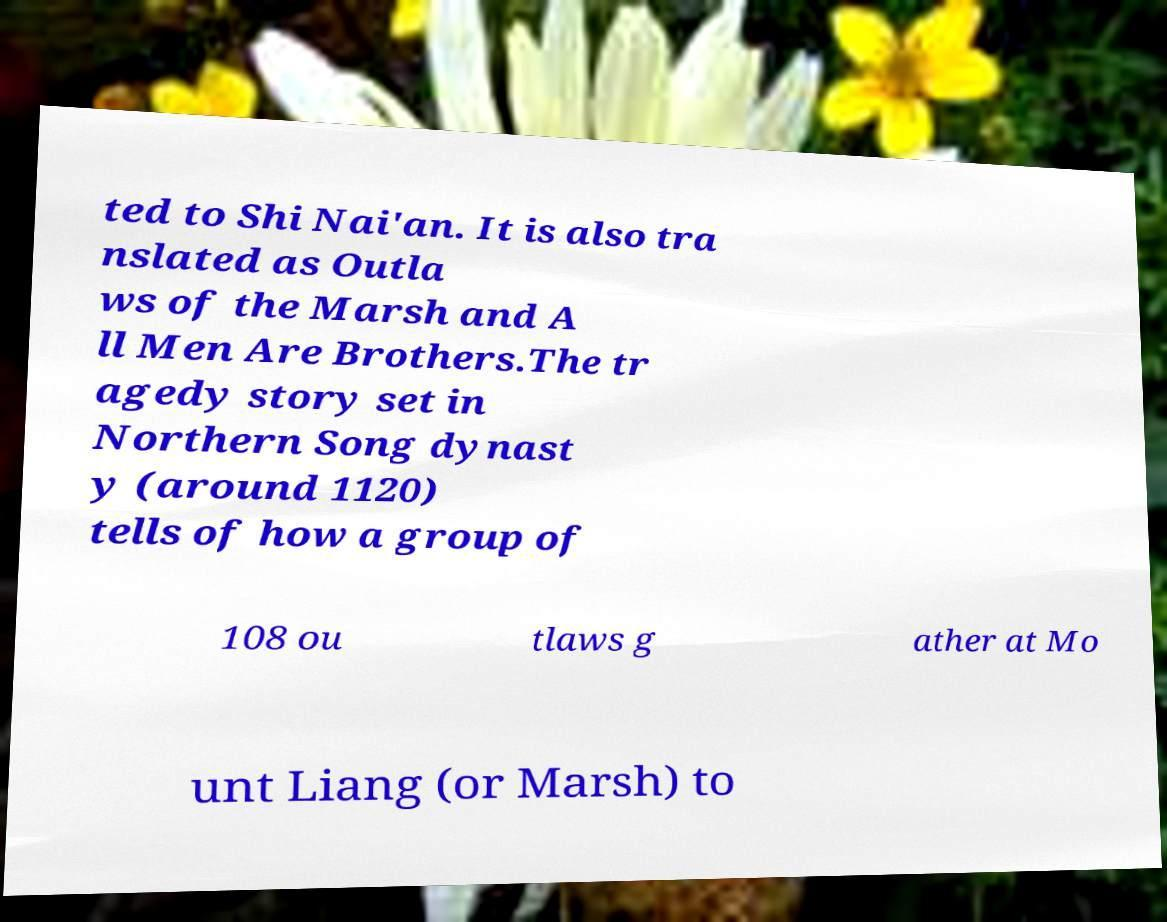Please identify and transcribe the text found in this image. ted to Shi Nai'an. It is also tra nslated as Outla ws of the Marsh and A ll Men Are Brothers.The tr agedy story set in Northern Song dynast y (around 1120) tells of how a group of 108 ou tlaws g ather at Mo unt Liang (or Marsh) to 